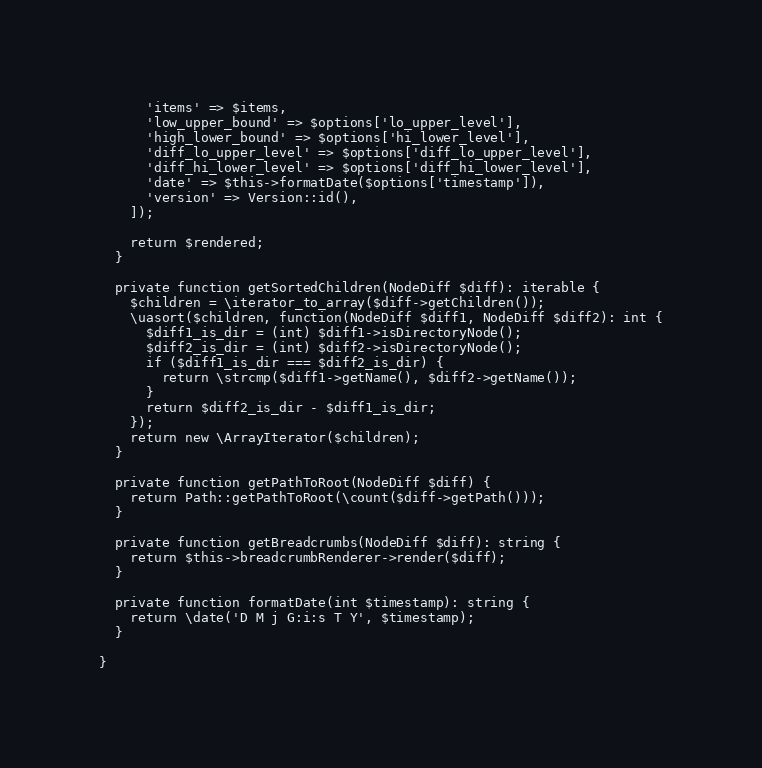<code> <loc_0><loc_0><loc_500><loc_500><_PHP_>      'items' => $items,
      'low_upper_bound' => $options['lo_upper_level'],
      'high_lower_bound' => $options['hi_lower_level'],
      'diff_lo_upper_level' => $options['diff_lo_upper_level'],
      'diff_hi_lower_level' => $options['diff_hi_lower_level'],
      'date' => $this->formatDate($options['timestamp']),
      'version' => Version::id(),
    ]);

    return $rendered;
  }

  private function getSortedChildren(NodeDiff $diff): iterable {
    $children = \iterator_to_array($diff->getChildren());
    \uasort($children, function(NodeDiff $diff1, NodeDiff $diff2): int {
      $diff1_is_dir = (int) $diff1->isDirectoryNode();
      $diff2_is_dir = (int) $diff2->isDirectoryNode();
      if ($diff1_is_dir === $diff2_is_dir) {
        return \strcmp($diff1->getName(), $diff2->getName());
      }
      return $diff2_is_dir - $diff1_is_dir;
    });
    return new \ArrayIterator($children);
  }

  private function getPathToRoot(NodeDiff $diff) {
    return Path::getPathToRoot(\count($diff->getPath()));
  }

  private function getBreadcrumbs(NodeDiff $diff): string {
    return $this->breadcrumbRenderer->render($diff);
  }

  private function formatDate(int $timestamp): string {
    return \date('D M j G:i:s T Y', $timestamp);
  }

}
</code> 